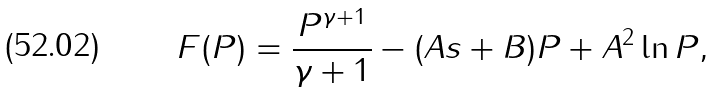<formula> <loc_0><loc_0><loc_500><loc_500>F ( P ) = \frac { P ^ { \gamma + 1 } } { \gamma + 1 } - ( A s + B ) P + A ^ { 2 } \ln P ,</formula> 